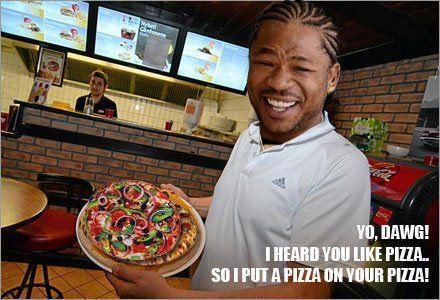How many pizzas can be seen?
Give a very brief answer. 1. How many blue boats are in the picture?
Give a very brief answer. 0. 